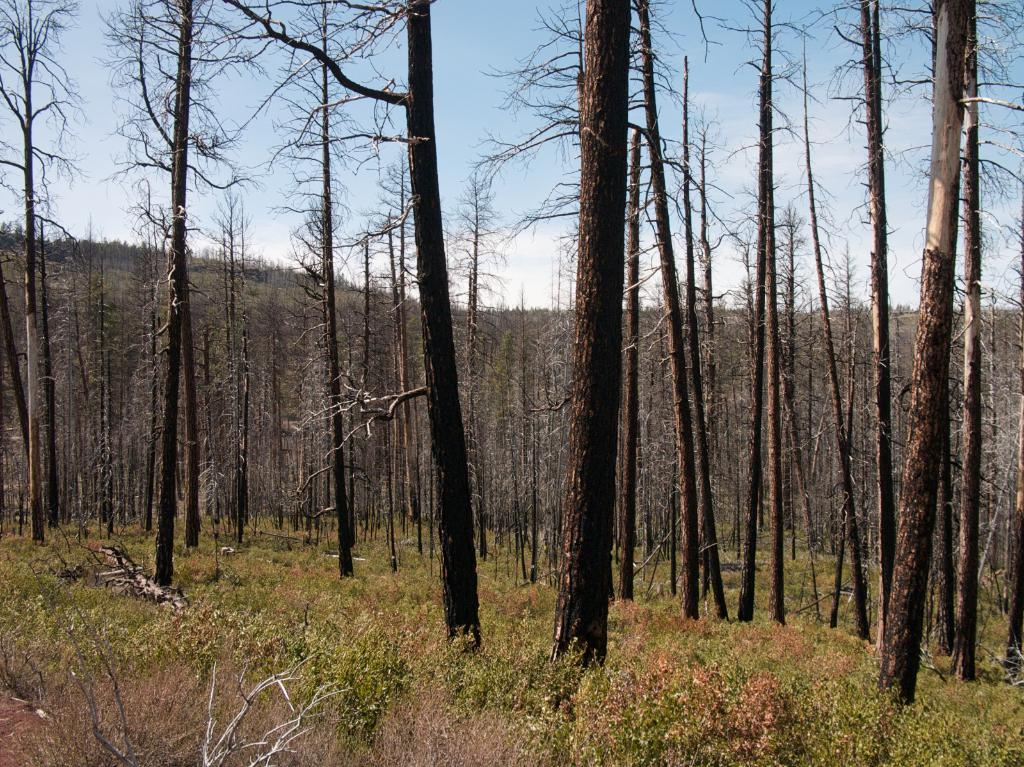What type of vegetation is in the center of the image? There are trees in the center of the image. What type of ground cover is at the bottom of the image? There is grass at the bottom of the image. What can be seen in the background of the image? The sky is visible in the background of the image. How many bananas are hanging from the trees in the image? There are no bananas present in the image; it features trees without any fruit. Can you see a plane flying in the sky in the image? There is no plane visible in the sky in the image. 